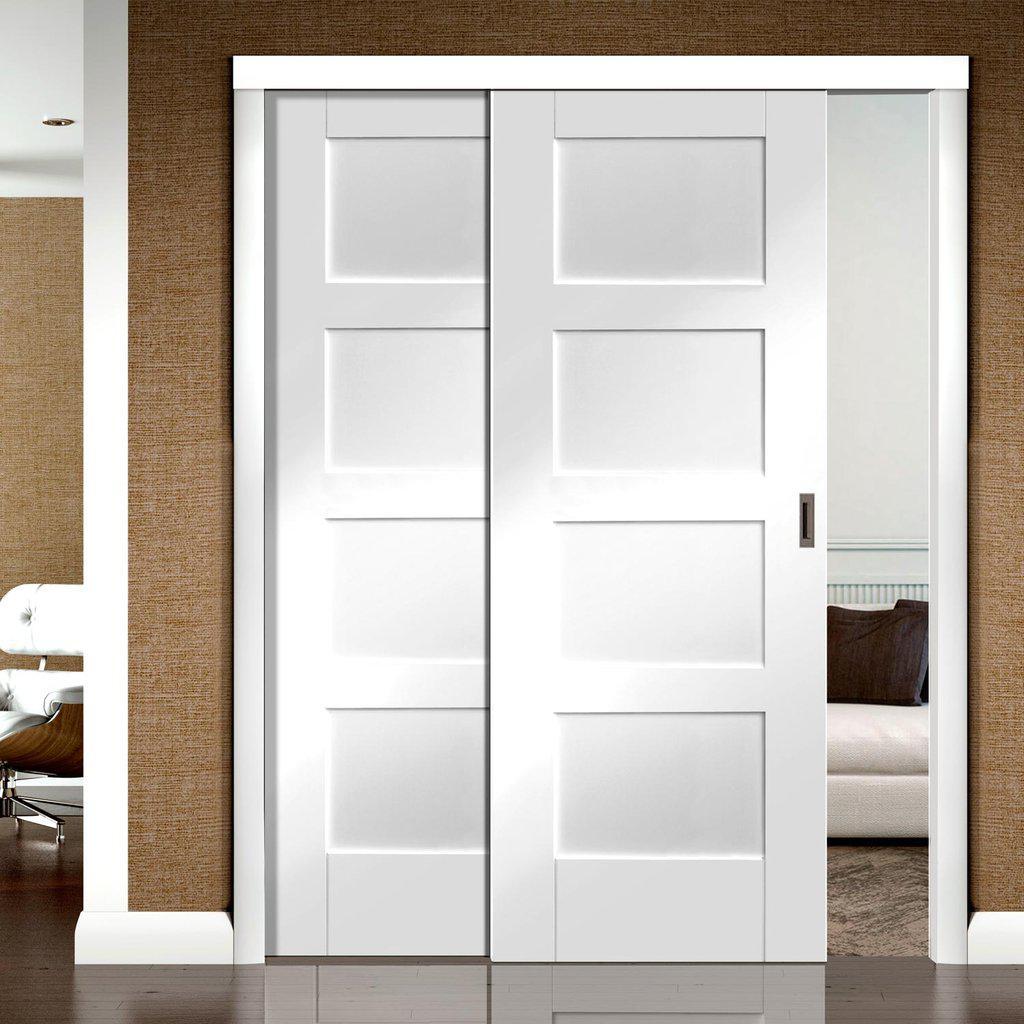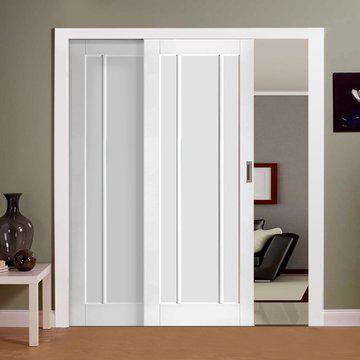The first image is the image on the left, the second image is the image on the right. Assess this claim about the two images: "An image shows a white-framed sliding door partly opened on the right, revealing a square framed item on the wall.". Correct or not? Answer yes or no. Yes. 